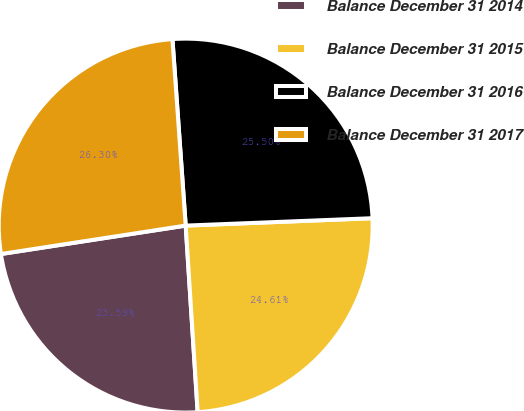<chart> <loc_0><loc_0><loc_500><loc_500><pie_chart><fcel>Balance December 31 2014<fcel>Balance December 31 2015<fcel>Balance December 31 2016<fcel>Balance December 31 2017<nl><fcel>23.59%<fcel>24.61%<fcel>25.5%<fcel>26.3%<nl></chart> 